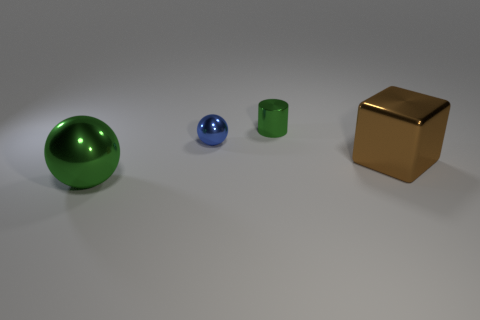Add 2 metallic blocks. How many objects exist? 6 Subtract all cylinders. How many objects are left? 3 Subtract all green objects. Subtract all tiny metal objects. How many objects are left? 0 Add 4 small metallic cylinders. How many small metallic cylinders are left? 5 Add 4 yellow rubber spheres. How many yellow rubber spheres exist? 4 Subtract 0 yellow spheres. How many objects are left? 4 